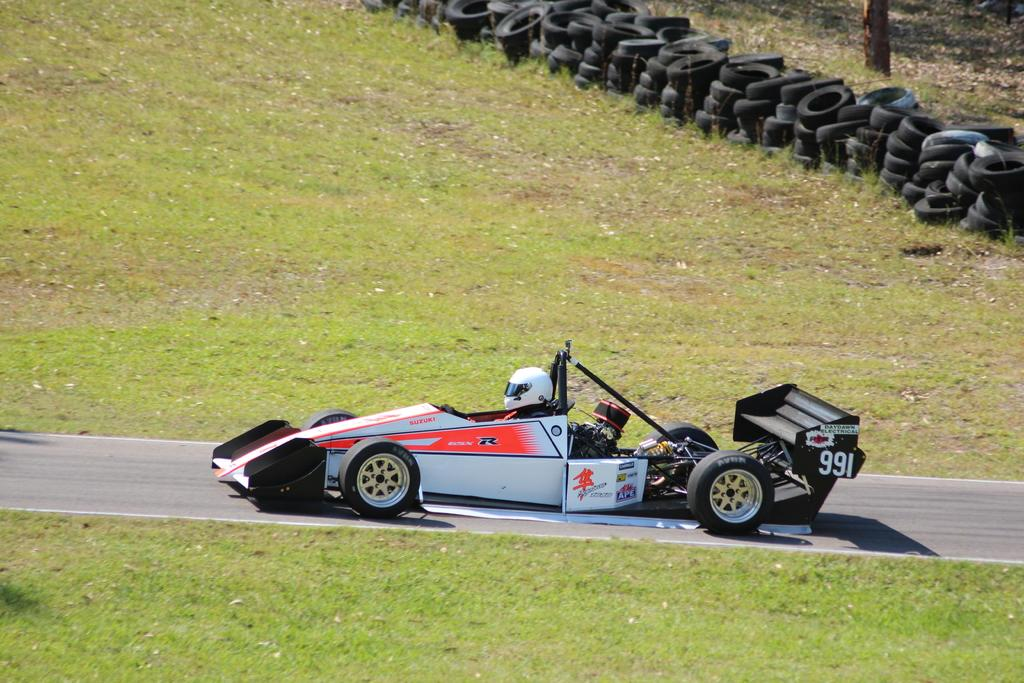What type of vehicle is in the image? There is a sports car in the image. Who is inside the sports car? A human is seated in the car. What protective gear is the person wearing? The person is wearing a helmet. What type of terrain is visible in the image? There is grass on the ground. What part of the car can be seen in the image? There are tires visible on the side. How many women are walking in the tub in the image? There are no women or tubs present in the image. 